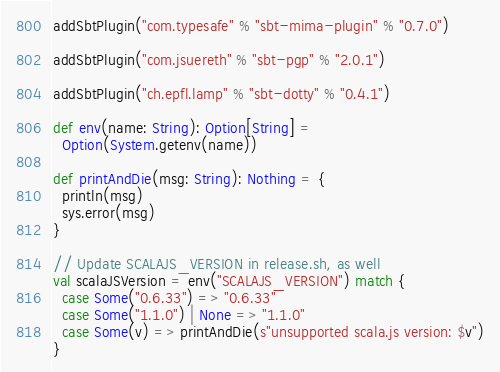Convert code to text. <code><loc_0><loc_0><loc_500><loc_500><_Scala_>addSbtPlugin("com.typesafe" % "sbt-mima-plugin" % "0.7.0")

addSbtPlugin("com.jsuereth" % "sbt-pgp" % "2.0.1")

addSbtPlugin("ch.epfl.lamp" % "sbt-dotty" % "0.4.1")

def env(name: String): Option[String] =
  Option(System.getenv(name))

def printAndDie(msg: String): Nothing = {
  println(msg)
  sys.error(msg)
}

// Update SCALAJS_VERSION in release.sh, as well
val scalaJSVersion = env("SCALAJS_VERSION") match {
  case Some("0.6.33") => "0.6.33"
  case Some("1.1.0") | None => "1.1.0"
  case Some(v) => printAndDie(s"unsupported scala.js version: $v")
}
</code> 